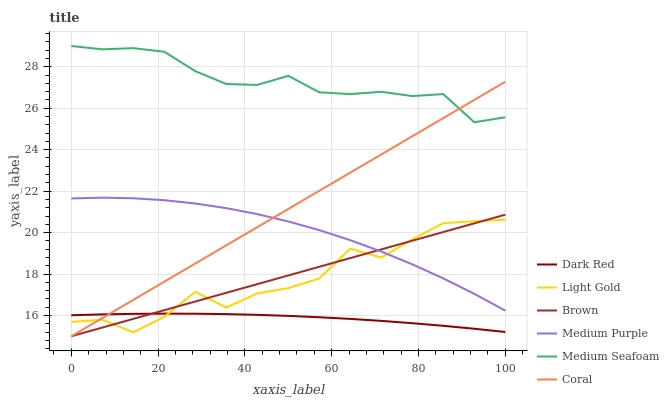Does Dark Red have the minimum area under the curve?
Answer yes or no. Yes. Does Medium Seafoam have the maximum area under the curve?
Answer yes or no. Yes. Does Coral have the minimum area under the curve?
Answer yes or no. No. Does Coral have the maximum area under the curve?
Answer yes or no. No. Is Coral the smoothest?
Answer yes or no. Yes. Is Light Gold the roughest?
Answer yes or no. Yes. Is Dark Red the smoothest?
Answer yes or no. No. Is Dark Red the roughest?
Answer yes or no. No. Does Brown have the lowest value?
Answer yes or no. Yes. Does Dark Red have the lowest value?
Answer yes or no. No. Does Medium Seafoam have the highest value?
Answer yes or no. Yes. Does Coral have the highest value?
Answer yes or no. No. Is Dark Red less than Medium Purple?
Answer yes or no. Yes. Is Medium Purple greater than Dark Red?
Answer yes or no. Yes. Does Medium Purple intersect Light Gold?
Answer yes or no. Yes. Is Medium Purple less than Light Gold?
Answer yes or no. No. Is Medium Purple greater than Light Gold?
Answer yes or no. No. Does Dark Red intersect Medium Purple?
Answer yes or no. No. 